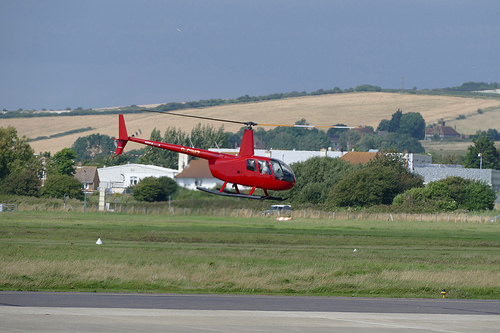<image>
Is there a helicopter on the ground? No. The helicopter is not positioned on the ground. They may be near each other, but the helicopter is not supported by or resting on top of the ground. 